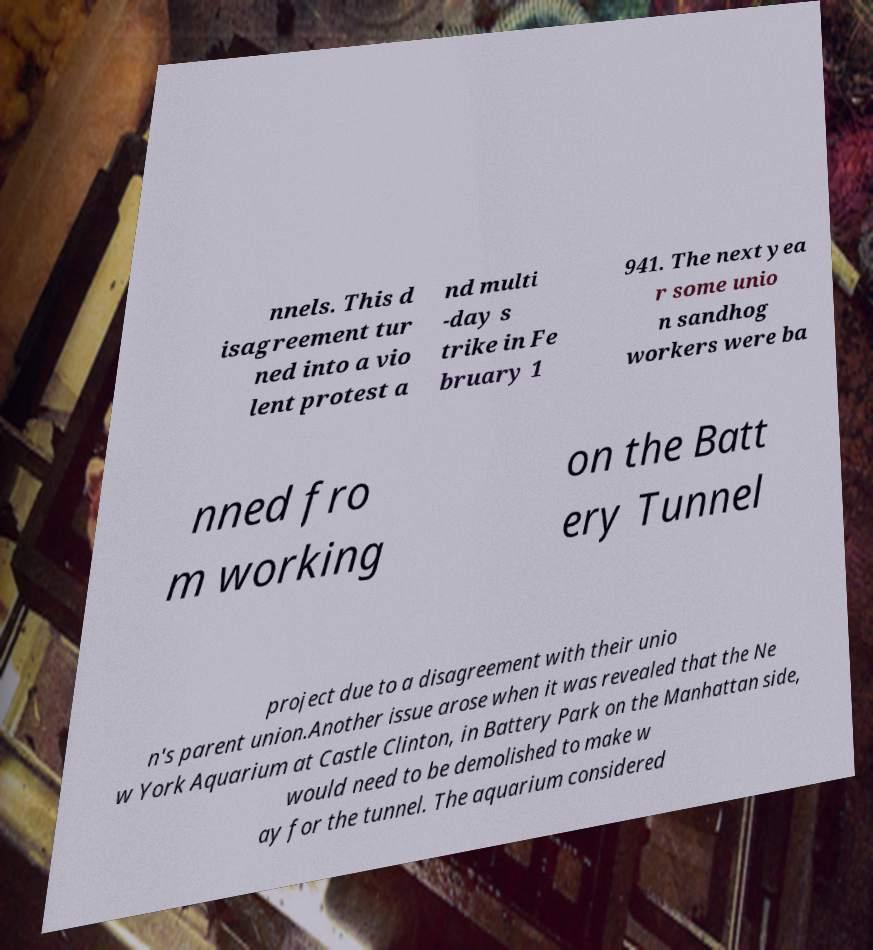For documentation purposes, I need the text within this image transcribed. Could you provide that? nnels. This d isagreement tur ned into a vio lent protest a nd multi -day s trike in Fe bruary 1 941. The next yea r some unio n sandhog workers were ba nned fro m working on the Batt ery Tunnel project due to a disagreement with their unio n's parent union.Another issue arose when it was revealed that the Ne w York Aquarium at Castle Clinton, in Battery Park on the Manhattan side, would need to be demolished to make w ay for the tunnel. The aquarium considered 